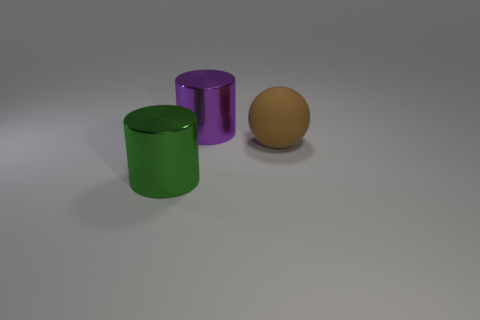There is a brown rubber thing; is its size the same as the metal cylinder in front of the matte ball?
Offer a very short reply. Yes. How big is the purple metallic cylinder on the left side of the brown rubber sphere behind the large metallic object that is in front of the large brown matte thing?
Keep it short and to the point. Large. What number of large brown matte balls are in front of the big brown rubber ball?
Provide a short and direct response. 0. What material is the large cylinder in front of the metal cylinder that is on the right side of the large green thing?
Keep it short and to the point. Metal. Do the purple metallic cylinder and the green shiny object have the same size?
Provide a succinct answer. Yes. What number of objects are either cylinders that are behind the large green shiny thing or large cylinders behind the big green shiny cylinder?
Ensure brevity in your answer.  1. Is the number of large matte things that are behind the large purple metallic cylinder greater than the number of big blue matte balls?
Offer a very short reply. No. How many other things are the same shape as the large purple thing?
Make the answer very short. 1. What is the thing that is right of the green metal thing and left of the large matte thing made of?
Give a very brief answer. Metal. How many objects are tiny purple cubes or rubber objects?
Give a very brief answer. 1. 